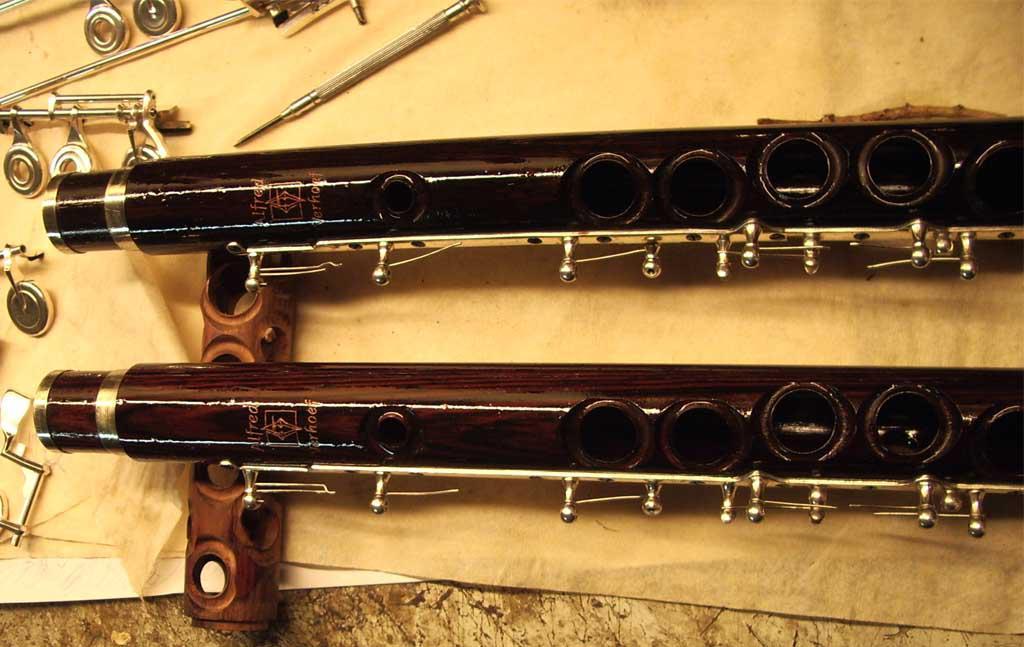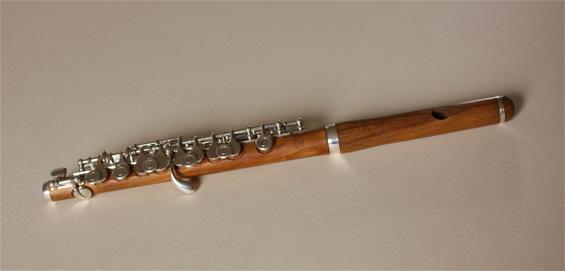The first image is the image on the left, the second image is the image on the right. Given the left and right images, does the statement "There is exactly one assembled flute in the left image." hold true? Answer yes or no. No. The first image is the image on the left, the second image is the image on the right. Assess this claim about the two images: "There are two flutes and one of them is in two pieces.". Correct or not? Answer yes or no. No. 